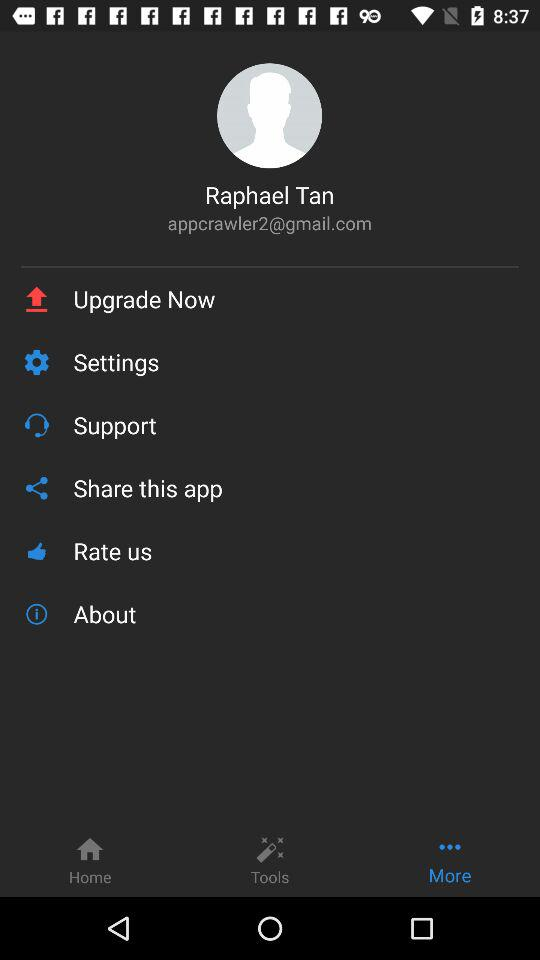Which tab is selected? The selected tab is "More". 